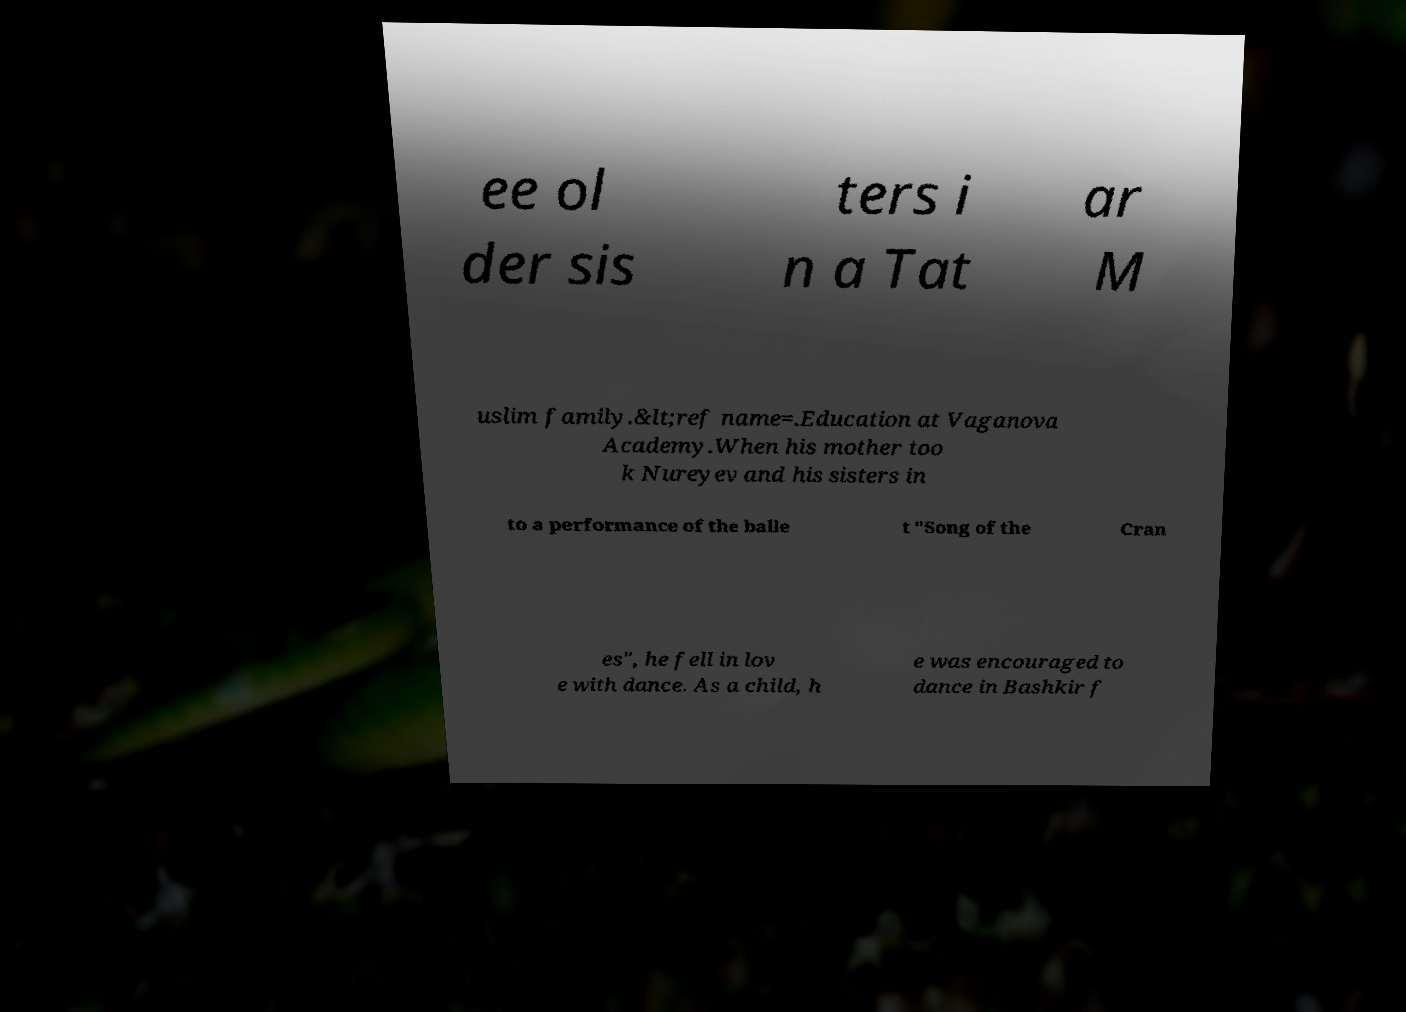Please read and relay the text visible in this image. What does it say? ee ol der sis ters i n a Tat ar M uslim family.&lt;ref name=.Education at Vaganova Academy.When his mother too k Nureyev and his sisters in to a performance of the balle t "Song of the Cran es", he fell in lov e with dance. As a child, h e was encouraged to dance in Bashkir f 